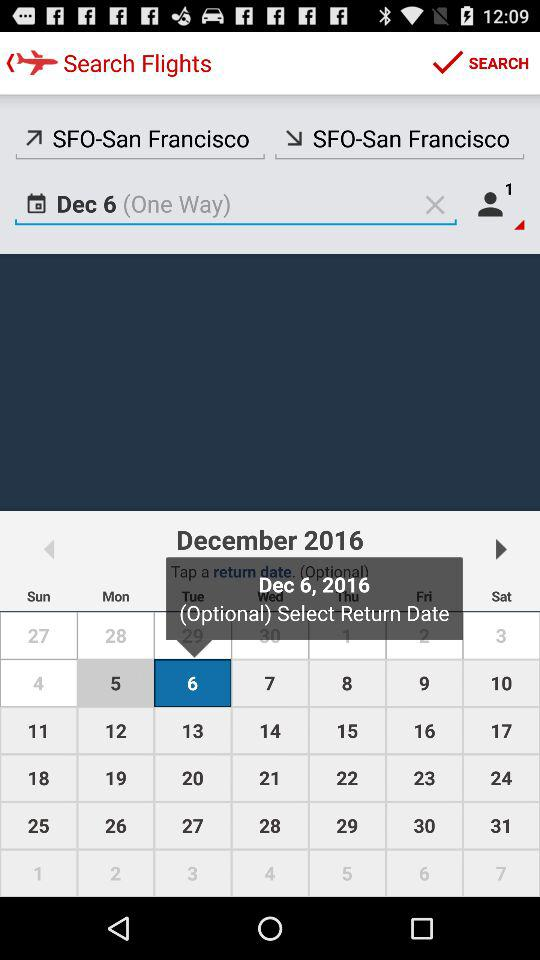How many passengers are being searched for?
Answer the question using a single word or phrase. 1 